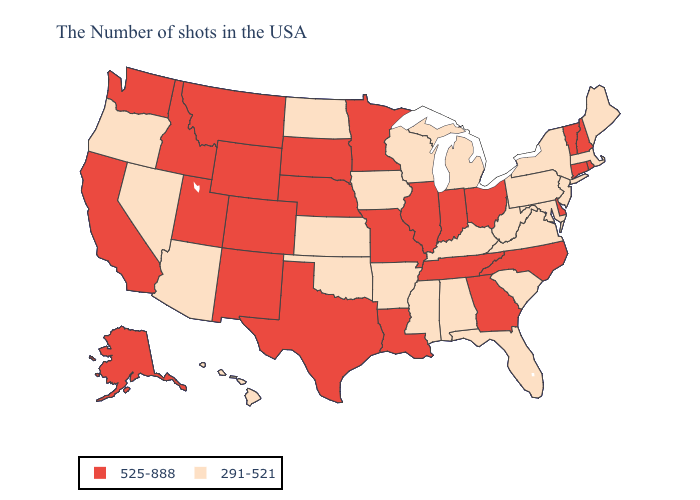What is the lowest value in states that border South Dakota?
Be succinct. 291-521. Name the states that have a value in the range 291-521?
Answer briefly. Maine, Massachusetts, New York, New Jersey, Maryland, Pennsylvania, Virginia, South Carolina, West Virginia, Florida, Michigan, Kentucky, Alabama, Wisconsin, Mississippi, Arkansas, Iowa, Kansas, Oklahoma, North Dakota, Arizona, Nevada, Oregon, Hawaii. Name the states that have a value in the range 525-888?
Keep it brief. Rhode Island, New Hampshire, Vermont, Connecticut, Delaware, North Carolina, Ohio, Georgia, Indiana, Tennessee, Illinois, Louisiana, Missouri, Minnesota, Nebraska, Texas, South Dakota, Wyoming, Colorado, New Mexico, Utah, Montana, Idaho, California, Washington, Alaska. Name the states that have a value in the range 525-888?
Keep it brief. Rhode Island, New Hampshire, Vermont, Connecticut, Delaware, North Carolina, Ohio, Georgia, Indiana, Tennessee, Illinois, Louisiana, Missouri, Minnesota, Nebraska, Texas, South Dakota, Wyoming, Colorado, New Mexico, Utah, Montana, Idaho, California, Washington, Alaska. What is the highest value in the Northeast ?
Give a very brief answer. 525-888. What is the value of Michigan?
Short answer required. 291-521. What is the lowest value in the West?
Short answer required. 291-521. Among the states that border Connecticut , does New York have the lowest value?
Quick response, please. Yes. Does South Carolina have a higher value than New Mexico?
Be succinct. No. How many symbols are there in the legend?
Answer briefly. 2. Name the states that have a value in the range 525-888?
Concise answer only. Rhode Island, New Hampshire, Vermont, Connecticut, Delaware, North Carolina, Ohio, Georgia, Indiana, Tennessee, Illinois, Louisiana, Missouri, Minnesota, Nebraska, Texas, South Dakota, Wyoming, Colorado, New Mexico, Utah, Montana, Idaho, California, Washington, Alaska. Is the legend a continuous bar?
Keep it brief. No. Does Colorado have the lowest value in the USA?
Give a very brief answer. No. Name the states that have a value in the range 525-888?
Be succinct. Rhode Island, New Hampshire, Vermont, Connecticut, Delaware, North Carolina, Ohio, Georgia, Indiana, Tennessee, Illinois, Louisiana, Missouri, Minnesota, Nebraska, Texas, South Dakota, Wyoming, Colorado, New Mexico, Utah, Montana, Idaho, California, Washington, Alaska. Which states hav the highest value in the Northeast?
Keep it brief. Rhode Island, New Hampshire, Vermont, Connecticut. 